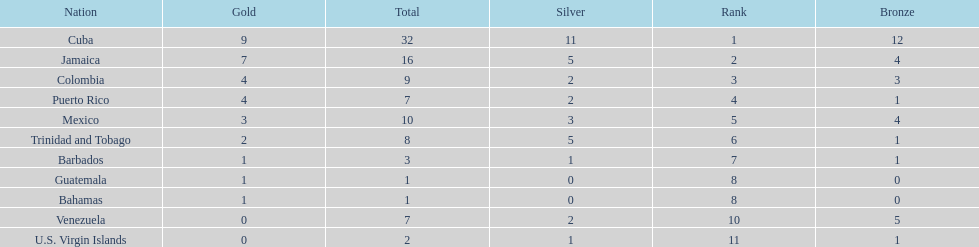What teams had four gold medals? Colombia, Puerto Rico. Of these two, which team only had one bronze medal? Puerto Rico. 